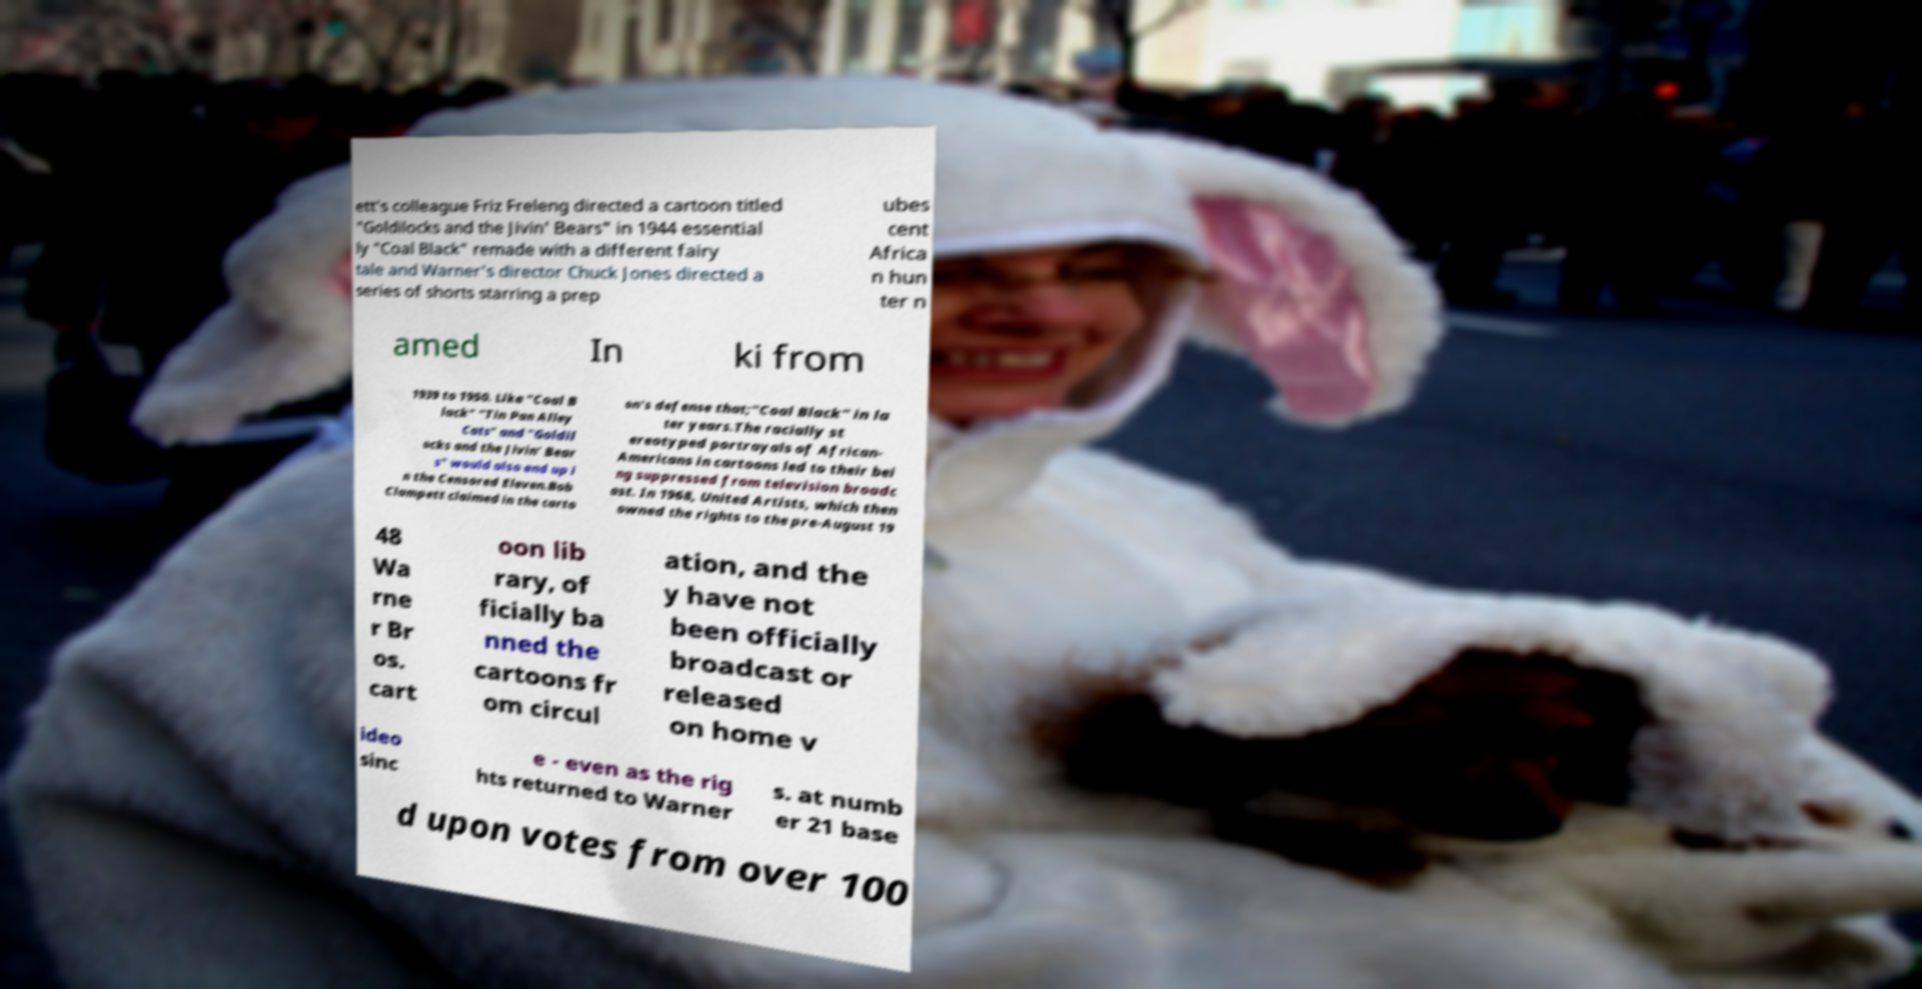For documentation purposes, I need the text within this image transcribed. Could you provide that? ett's colleague Friz Freleng directed a cartoon titled "Goldilocks and the Jivin' Bears" in 1944 essential ly "Coal Black" remade with a different fairy tale and Warner's director Chuck Jones directed a series of shorts starring a prep ubes cent Africa n hun ter n amed In ki from 1939 to 1950. Like "Coal B lack" "Tin Pan Alley Cats" and "Goldil ocks and the Jivin' Bear s" would also end up i n the Censored Eleven.Bob Clampett claimed in the carto on's defense that;"Coal Black" in la ter years.The racially st ereotyped portrayals of African- Americans in cartoons led to their bei ng suppressed from television broadc ast. In 1968, United Artists, which then owned the rights to the pre-August 19 48 Wa rne r Br os. cart oon lib rary, of ficially ba nned the cartoons fr om circul ation, and the y have not been officially broadcast or released on home v ideo sinc e - even as the rig hts returned to Warner s. at numb er 21 base d upon votes from over 100 